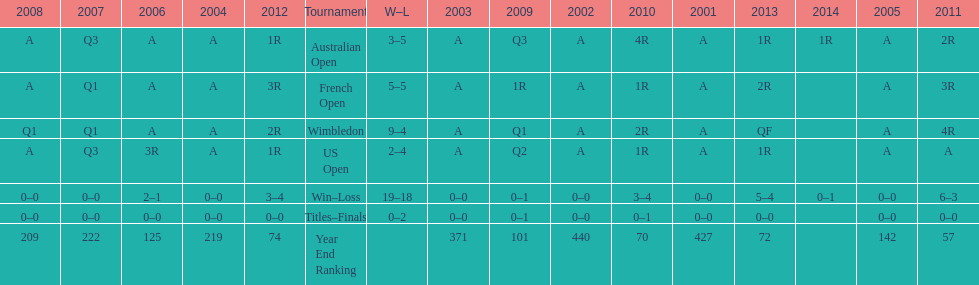Which tournament has the largest total win record? Wimbledon. 